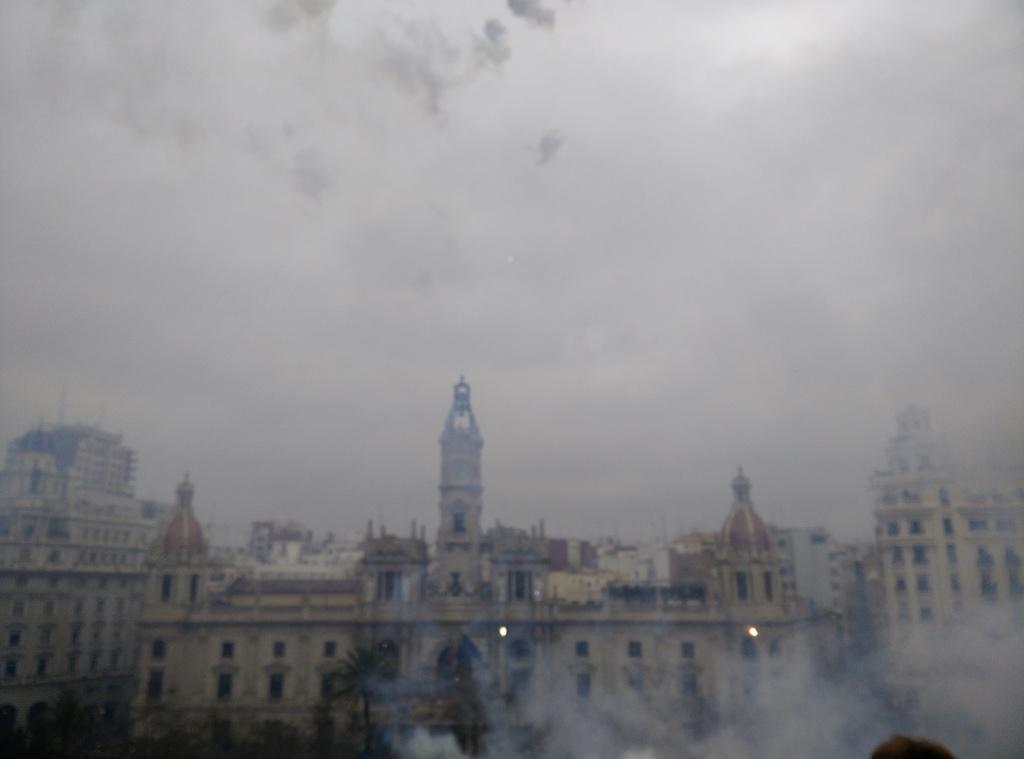What type of structures can be seen in the image? There are buildings in the image. What is visible in the background of the image? There is a sky visible in the background of the image. What type of key is used to unlock the approval process in the image? There is no key or approval process present in the image; it only features buildings and a sky. 